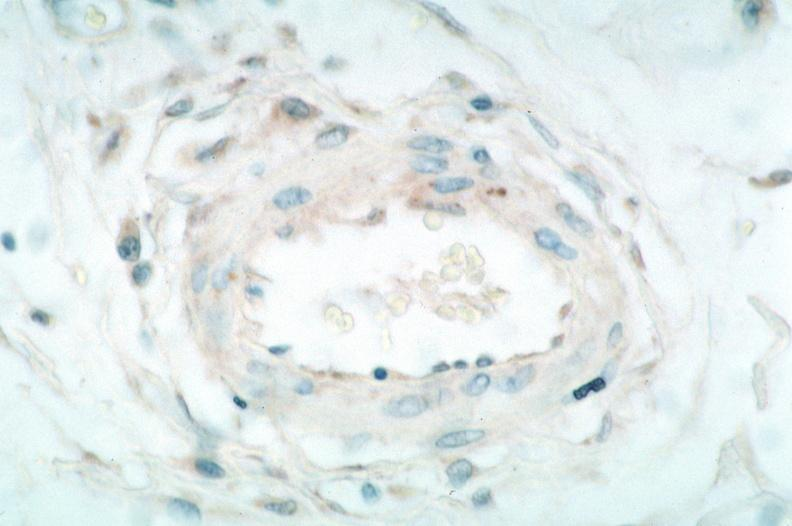where is this from?
Answer the question using a single word or phrase. Vasculature 